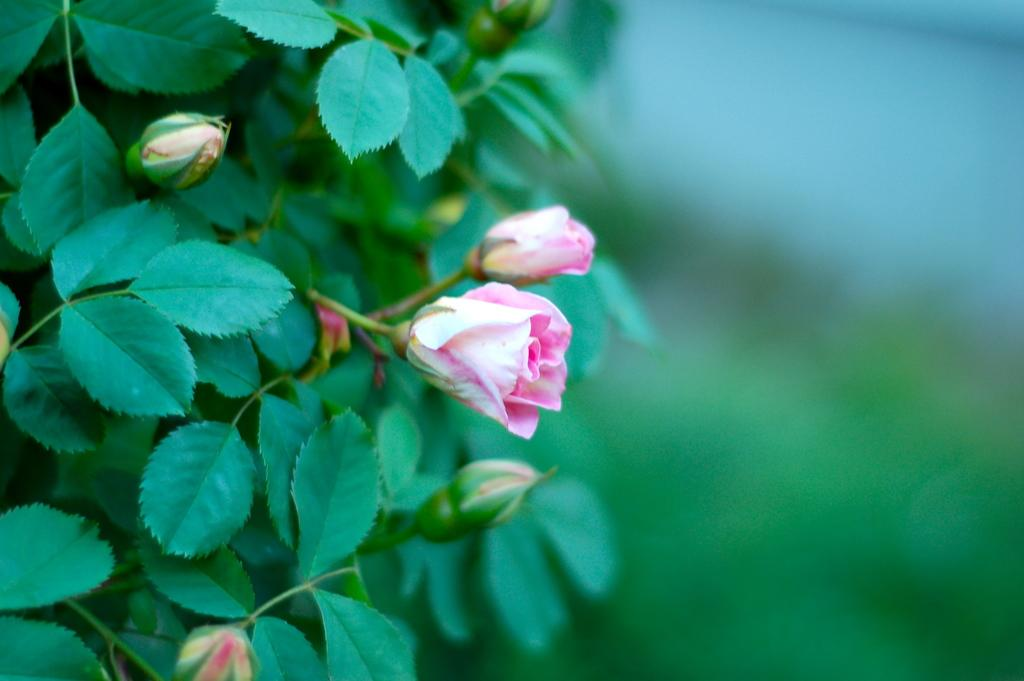What types of flowers are in the image? There are two white and pink color flowers in the image. What color are the leaves in the image? The leaves in the image are green. How would you describe the background of the image? The background of the image is blurred. Where is the hen located in the image? There is no hen present in the image. What type of kettle can be seen in the image? There is no kettle present in the image. 